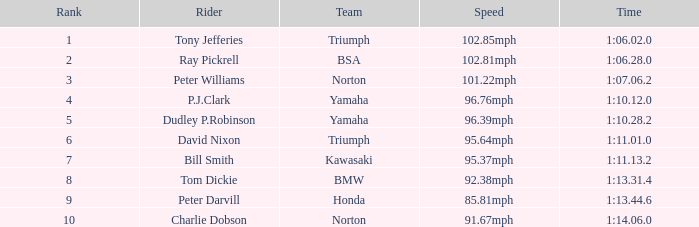0 Tony Jefferies. 